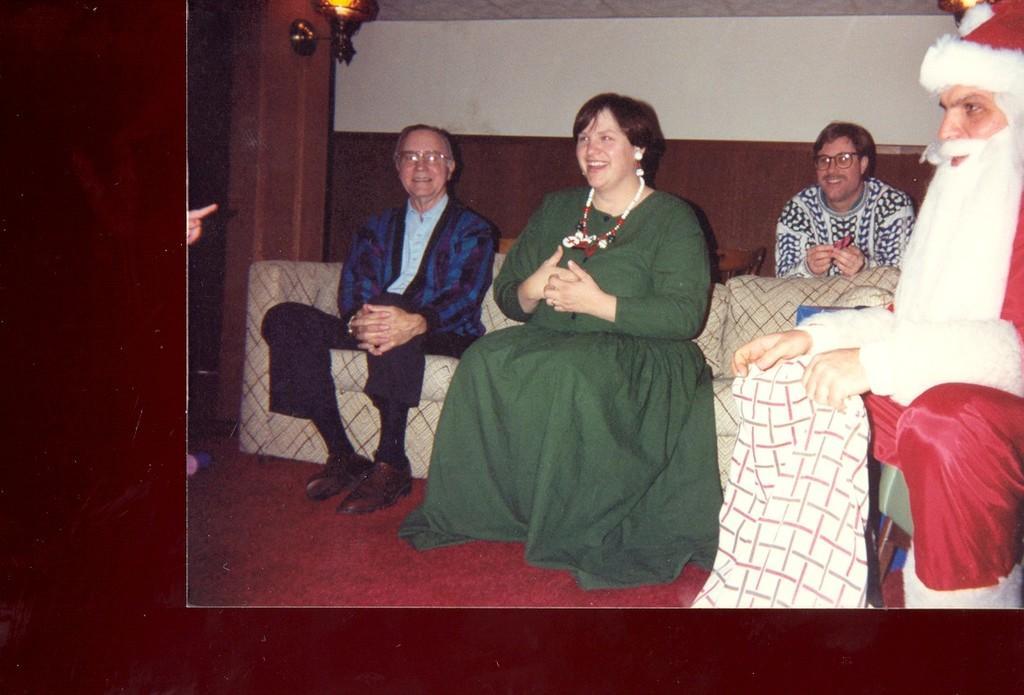Describe this image in one or two sentences. In this image, we can see a photo, in that photo, we can see some people sitting on the sofa. On the right side, we can see a person wearing Christmas father dress. 